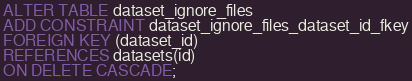<code> <loc_0><loc_0><loc_500><loc_500><_SQL_>ALTER TABLE dataset_ignore_files
ADD CONSTRAINT dataset_ignore_files_dataset_id_fkey
FOREIGN KEY (dataset_id)
REFERENCES datasets(id)
ON DELETE CASCADE;
</code> 